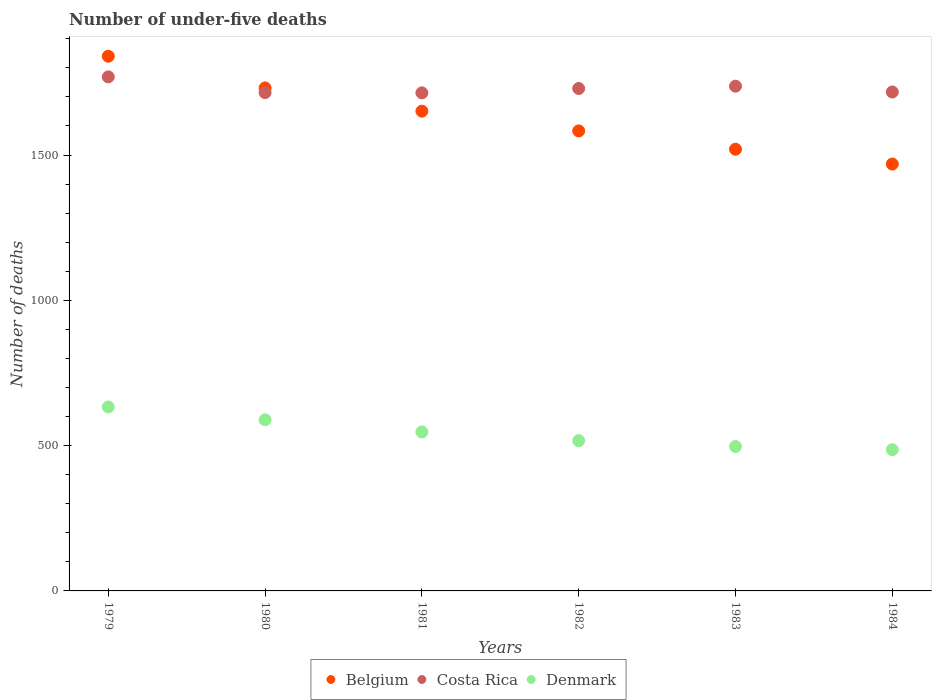How many different coloured dotlines are there?
Your response must be concise. 3. What is the number of under-five deaths in Denmark in 1983?
Give a very brief answer. 497. Across all years, what is the maximum number of under-five deaths in Denmark?
Your answer should be very brief. 633. Across all years, what is the minimum number of under-five deaths in Costa Rica?
Make the answer very short. 1714. In which year was the number of under-five deaths in Belgium maximum?
Give a very brief answer. 1979. What is the total number of under-five deaths in Belgium in the graph?
Provide a short and direct response. 9794. What is the difference between the number of under-five deaths in Costa Rica in 1980 and that in 1984?
Your response must be concise. -2. What is the difference between the number of under-five deaths in Belgium in 1984 and the number of under-five deaths in Costa Rica in 1981?
Keep it short and to the point. -245. What is the average number of under-five deaths in Belgium per year?
Give a very brief answer. 1632.33. In the year 1982, what is the difference between the number of under-five deaths in Denmark and number of under-five deaths in Costa Rica?
Offer a very short reply. -1212. What is the ratio of the number of under-five deaths in Belgium in 1979 to that in 1980?
Your answer should be very brief. 1.06. Is the difference between the number of under-five deaths in Denmark in 1981 and 1983 greater than the difference between the number of under-five deaths in Costa Rica in 1981 and 1983?
Your answer should be compact. Yes. What is the difference between the highest and the lowest number of under-five deaths in Denmark?
Give a very brief answer. 147. In how many years, is the number of under-five deaths in Belgium greater than the average number of under-five deaths in Belgium taken over all years?
Ensure brevity in your answer.  3. Is it the case that in every year, the sum of the number of under-five deaths in Belgium and number of under-five deaths in Denmark  is greater than the number of under-five deaths in Costa Rica?
Offer a very short reply. Yes. Does the number of under-five deaths in Costa Rica monotonically increase over the years?
Ensure brevity in your answer.  No. Is the number of under-five deaths in Belgium strictly greater than the number of under-five deaths in Costa Rica over the years?
Ensure brevity in your answer.  No. How many dotlines are there?
Offer a very short reply. 3. How many years are there in the graph?
Offer a terse response. 6. What is the difference between two consecutive major ticks on the Y-axis?
Your response must be concise. 500. Are the values on the major ticks of Y-axis written in scientific E-notation?
Keep it short and to the point. No. Does the graph contain any zero values?
Offer a terse response. No. Where does the legend appear in the graph?
Keep it short and to the point. Bottom center. How many legend labels are there?
Offer a very short reply. 3. What is the title of the graph?
Provide a short and direct response. Number of under-five deaths. Does "High income" appear as one of the legend labels in the graph?
Offer a terse response. No. What is the label or title of the Y-axis?
Make the answer very short. Number of deaths. What is the Number of deaths of Belgium in 1979?
Keep it short and to the point. 1840. What is the Number of deaths in Costa Rica in 1979?
Provide a succinct answer. 1769. What is the Number of deaths in Denmark in 1979?
Keep it short and to the point. 633. What is the Number of deaths of Belgium in 1980?
Ensure brevity in your answer.  1731. What is the Number of deaths of Costa Rica in 1980?
Provide a short and direct response. 1715. What is the Number of deaths of Denmark in 1980?
Your answer should be compact. 589. What is the Number of deaths in Belgium in 1981?
Your answer should be compact. 1651. What is the Number of deaths in Costa Rica in 1981?
Give a very brief answer. 1714. What is the Number of deaths in Denmark in 1981?
Ensure brevity in your answer.  547. What is the Number of deaths of Belgium in 1982?
Keep it short and to the point. 1583. What is the Number of deaths in Costa Rica in 1982?
Give a very brief answer. 1729. What is the Number of deaths of Denmark in 1982?
Provide a succinct answer. 517. What is the Number of deaths of Belgium in 1983?
Make the answer very short. 1520. What is the Number of deaths in Costa Rica in 1983?
Your response must be concise. 1737. What is the Number of deaths of Denmark in 1983?
Ensure brevity in your answer.  497. What is the Number of deaths of Belgium in 1984?
Provide a succinct answer. 1469. What is the Number of deaths in Costa Rica in 1984?
Make the answer very short. 1717. What is the Number of deaths of Denmark in 1984?
Offer a terse response. 486. Across all years, what is the maximum Number of deaths in Belgium?
Give a very brief answer. 1840. Across all years, what is the maximum Number of deaths in Costa Rica?
Make the answer very short. 1769. Across all years, what is the maximum Number of deaths of Denmark?
Your answer should be compact. 633. Across all years, what is the minimum Number of deaths of Belgium?
Offer a terse response. 1469. Across all years, what is the minimum Number of deaths in Costa Rica?
Ensure brevity in your answer.  1714. Across all years, what is the minimum Number of deaths of Denmark?
Offer a terse response. 486. What is the total Number of deaths in Belgium in the graph?
Your response must be concise. 9794. What is the total Number of deaths of Costa Rica in the graph?
Your answer should be very brief. 1.04e+04. What is the total Number of deaths of Denmark in the graph?
Keep it short and to the point. 3269. What is the difference between the Number of deaths in Belgium in 1979 and that in 1980?
Provide a short and direct response. 109. What is the difference between the Number of deaths in Costa Rica in 1979 and that in 1980?
Your answer should be compact. 54. What is the difference between the Number of deaths of Denmark in 1979 and that in 1980?
Offer a very short reply. 44. What is the difference between the Number of deaths in Belgium in 1979 and that in 1981?
Ensure brevity in your answer.  189. What is the difference between the Number of deaths of Belgium in 1979 and that in 1982?
Ensure brevity in your answer.  257. What is the difference between the Number of deaths in Costa Rica in 1979 and that in 1982?
Your response must be concise. 40. What is the difference between the Number of deaths of Denmark in 1979 and that in 1982?
Make the answer very short. 116. What is the difference between the Number of deaths in Belgium in 1979 and that in 1983?
Your answer should be very brief. 320. What is the difference between the Number of deaths in Denmark in 1979 and that in 1983?
Keep it short and to the point. 136. What is the difference between the Number of deaths of Belgium in 1979 and that in 1984?
Ensure brevity in your answer.  371. What is the difference between the Number of deaths of Costa Rica in 1979 and that in 1984?
Your answer should be compact. 52. What is the difference between the Number of deaths of Denmark in 1979 and that in 1984?
Give a very brief answer. 147. What is the difference between the Number of deaths of Costa Rica in 1980 and that in 1981?
Give a very brief answer. 1. What is the difference between the Number of deaths of Denmark in 1980 and that in 1981?
Your answer should be very brief. 42. What is the difference between the Number of deaths in Belgium in 1980 and that in 1982?
Offer a terse response. 148. What is the difference between the Number of deaths in Costa Rica in 1980 and that in 1982?
Your answer should be very brief. -14. What is the difference between the Number of deaths in Denmark in 1980 and that in 1982?
Give a very brief answer. 72. What is the difference between the Number of deaths of Belgium in 1980 and that in 1983?
Your answer should be very brief. 211. What is the difference between the Number of deaths of Costa Rica in 1980 and that in 1983?
Provide a short and direct response. -22. What is the difference between the Number of deaths of Denmark in 1980 and that in 1983?
Keep it short and to the point. 92. What is the difference between the Number of deaths in Belgium in 1980 and that in 1984?
Your answer should be compact. 262. What is the difference between the Number of deaths of Denmark in 1980 and that in 1984?
Your answer should be compact. 103. What is the difference between the Number of deaths in Denmark in 1981 and that in 1982?
Ensure brevity in your answer.  30. What is the difference between the Number of deaths of Belgium in 1981 and that in 1983?
Provide a succinct answer. 131. What is the difference between the Number of deaths in Denmark in 1981 and that in 1983?
Offer a terse response. 50. What is the difference between the Number of deaths of Belgium in 1981 and that in 1984?
Offer a terse response. 182. What is the difference between the Number of deaths of Belgium in 1982 and that in 1983?
Your response must be concise. 63. What is the difference between the Number of deaths of Belgium in 1982 and that in 1984?
Provide a short and direct response. 114. What is the difference between the Number of deaths of Costa Rica in 1982 and that in 1984?
Your answer should be compact. 12. What is the difference between the Number of deaths of Costa Rica in 1983 and that in 1984?
Provide a succinct answer. 20. What is the difference between the Number of deaths in Denmark in 1983 and that in 1984?
Provide a short and direct response. 11. What is the difference between the Number of deaths in Belgium in 1979 and the Number of deaths in Costa Rica in 1980?
Your answer should be compact. 125. What is the difference between the Number of deaths of Belgium in 1979 and the Number of deaths of Denmark in 1980?
Offer a terse response. 1251. What is the difference between the Number of deaths in Costa Rica in 1979 and the Number of deaths in Denmark in 1980?
Your answer should be very brief. 1180. What is the difference between the Number of deaths of Belgium in 1979 and the Number of deaths of Costa Rica in 1981?
Provide a succinct answer. 126. What is the difference between the Number of deaths in Belgium in 1979 and the Number of deaths in Denmark in 1981?
Your answer should be very brief. 1293. What is the difference between the Number of deaths of Costa Rica in 1979 and the Number of deaths of Denmark in 1981?
Your response must be concise. 1222. What is the difference between the Number of deaths of Belgium in 1979 and the Number of deaths of Costa Rica in 1982?
Provide a succinct answer. 111. What is the difference between the Number of deaths of Belgium in 1979 and the Number of deaths of Denmark in 1982?
Provide a short and direct response. 1323. What is the difference between the Number of deaths of Costa Rica in 1979 and the Number of deaths of Denmark in 1982?
Your response must be concise. 1252. What is the difference between the Number of deaths in Belgium in 1979 and the Number of deaths in Costa Rica in 1983?
Ensure brevity in your answer.  103. What is the difference between the Number of deaths in Belgium in 1979 and the Number of deaths in Denmark in 1983?
Ensure brevity in your answer.  1343. What is the difference between the Number of deaths of Costa Rica in 1979 and the Number of deaths of Denmark in 1983?
Your answer should be compact. 1272. What is the difference between the Number of deaths of Belgium in 1979 and the Number of deaths of Costa Rica in 1984?
Your answer should be very brief. 123. What is the difference between the Number of deaths of Belgium in 1979 and the Number of deaths of Denmark in 1984?
Ensure brevity in your answer.  1354. What is the difference between the Number of deaths in Costa Rica in 1979 and the Number of deaths in Denmark in 1984?
Provide a short and direct response. 1283. What is the difference between the Number of deaths in Belgium in 1980 and the Number of deaths in Denmark in 1981?
Keep it short and to the point. 1184. What is the difference between the Number of deaths in Costa Rica in 1980 and the Number of deaths in Denmark in 1981?
Keep it short and to the point. 1168. What is the difference between the Number of deaths of Belgium in 1980 and the Number of deaths of Denmark in 1982?
Provide a succinct answer. 1214. What is the difference between the Number of deaths in Costa Rica in 1980 and the Number of deaths in Denmark in 1982?
Keep it short and to the point. 1198. What is the difference between the Number of deaths in Belgium in 1980 and the Number of deaths in Denmark in 1983?
Your response must be concise. 1234. What is the difference between the Number of deaths of Costa Rica in 1980 and the Number of deaths of Denmark in 1983?
Your answer should be compact. 1218. What is the difference between the Number of deaths in Belgium in 1980 and the Number of deaths in Denmark in 1984?
Provide a succinct answer. 1245. What is the difference between the Number of deaths of Costa Rica in 1980 and the Number of deaths of Denmark in 1984?
Offer a terse response. 1229. What is the difference between the Number of deaths in Belgium in 1981 and the Number of deaths in Costa Rica in 1982?
Give a very brief answer. -78. What is the difference between the Number of deaths of Belgium in 1981 and the Number of deaths of Denmark in 1982?
Keep it short and to the point. 1134. What is the difference between the Number of deaths in Costa Rica in 1981 and the Number of deaths in Denmark in 1982?
Provide a short and direct response. 1197. What is the difference between the Number of deaths in Belgium in 1981 and the Number of deaths in Costa Rica in 1983?
Ensure brevity in your answer.  -86. What is the difference between the Number of deaths of Belgium in 1981 and the Number of deaths of Denmark in 1983?
Give a very brief answer. 1154. What is the difference between the Number of deaths in Costa Rica in 1981 and the Number of deaths in Denmark in 1983?
Your answer should be very brief. 1217. What is the difference between the Number of deaths in Belgium in 1981 and the Number of deaths in Costa Rica in 1984?
Make the answer very short. -66. What is the difference between the Number of deaths in Belgium in 1981 and the Number of deaths in Denmark in 1984?
Provide a succinct answer. 1165. What is the difference between the Number of deaths in Costa Rica in 1981 and the Number of deaths in Denmark in 1984?
Offer a terse response. 1228. What is the difference between the Number of deaths in Belgium in 1982 and the Number of deaths in Costa Rica in 1983?
Provide a short and direct response. -154. What is the difference between the Number of deaths in Belgium in 1982 and the Number of deaths in Denmark in 1983?
Give a very brief answer. 1086. What is the difference between the Number of deaths in Costa Rica in 1982 and the Number of deaths in Denmark in 1983?
Your response must be concise. 1232. What is the difference between the Number of deaths in Belgium in 1982 and the Number of deaths in Costa Rica in 1984?
Ensure brevity in your answer.  -134. What is the difference between the Number of deaths of Belgium in 1982 and the Number of deaths of Denmark in 1984?
Keep it short and to the point. 1097. What is the difference between the Number of deaths in Costa Rica in 1982 and the Number of deaths in Denmark in 1984?
Provide a succinct answer. 1243. What is the difference between the Number of deaths of Belgium in 1983 and the Number of deaths of Costa Rica in 1984?
Provide a short and direct response. -197. What is the difference between the Number of deaths of Belgium in 1983 and the Number of deaths of Denmark in 1984?
Keep it short and to the point. 1034. What is the difference between the Number of deaths in Costa Rica in 1983 and the Number of deaths in Denmark in 1984?
Your answer should be compact. 1251. What is the average Number of deaths of Belgium per year?
Your answer should be compact. 1632.33. What is the average Number of deaths of Costa Rica per year?
Your answer should be very brief. 1730.17. What is the average Number of deaths in Denmark per year?
Keep it short and to the point. 544.83. In the year 1979, what is the difference between the Number of deaths of Belgium and Number of deaths of Denmark?
Ensure brevity in your answer.  1207. In the year 1979, what is the difference between the Number of deaths in Costa Rica and Number of deaths in Denmark?
Provide a succinct answer. 1136. In the year 1980, what is the difference between the Number of deaths in Belgium and Number of deaths in Costa Rica?
Offer a terse response. 16. In the year 1980, what is the difference between the Number of deaths of Belgium and Number of deaths of Denmark?
Make the answer very short. 1142. In the year 1980, what is the difference between the Number of deaths of Costa Rica and Number of deaths of Denmark?
Provide a succinct answer. 1126. In the year 1981, what is the difference between the Number of deaths of Belgium and Number of deaths of Costa Rica?
Offer a very short reply. -63. In the year 1981, what is the difference between the Number of deaths in Belgium and Number of deaths in Denmark?
Provide a short and direct response. 1104. In the year 1981, what is the difference between the Number of deaths of Costa Rica and Number of deaths of Denmark?
Give a very brief answer. 1167. In the year 1982, what is the difference between the Number of deaths of Belgium and Number of deaths of Costa Rica?
Offer a very short reply. -146. In the year 1982, what is the difference between the Number of deaths in Belgium and Number of deaths in Denmark?
Provide a succinct answer. 1066. In the year 1982, what is the difference between the Number of deaths in Costa Rica and Number of deaths in Denmark?
Provide a short and direct response. 1212. In the year 1983, what is the difference between the Number of deaths of Belgium and Number of deaths of Costa Rica?
Give a very brief answer. -217. In the year 1983, what is the difference between the Number of deaths of Belgium and Number of deaths of Denmark?
Provide a short and direct response. 1023. In the year 1983, what is the difference between the Number of deaths in Costa Rica and Number of deaths in Denmark?
Your answer should be very brief. 1240. In the year 1984, what is the difference between the Number of deaths in Belgium and Number of deaths in Costa Rica?
Provide a succinct answer. -248. In the year 1984, what is the difference between the Number of deaths in Belgium and Number of deaths in Denmark?
Your response must be concise. 983. In the year 1984, what is the difference between the Number of deaths in Costa Rica and Number of deaths in Denmark?
Ensure brevity in your answer.  1231. What is the ratio of the Number of deaths in Belgium in 1979 to that in 1980?
Your answer should be very brief. 1.06. What is the ratio of the Number of deaths of Costa Rica in 1979 to that in 1980?
Ensure brevity in your answer.  1.03. What is the ratio of the Number of deaths of Denmark in 1979 to that in 1980?
Make the answer very short. 1.07. What is the ratio of the Number of deaths of Belgium in 1979 to that in 1981?
Give a very brief answer. 1.11. What is the ratio of the Number of deaths of Costa Rica in 1979 to that in 1981?
Offer a terse response. 1.03. What is the ratio of the Number of deaths in Denmark in 1979 to that in 1981?
Keep it short and to the point. 1.16. What is the ratio of the Number of deaths in Belgium in 1979 to that in 1982?
Keep it short and to the point. 1.16. What is the ratio of the Number of deaths of Costa Rica in 1979 to that in 1982?
Your answer should be very brief. 1.02. What is the ratio of the Number of deaths in Denmark in 1979 to that in 1982?
Ensure brevity in your answer.  1.22. What is the ratio of the Number of deaths of Belgium in 1979 to that in 1983?
Ensure brevity in your answer.  1.21. What is the ratio of the Number of deaths of Costa Rica in 1979 to that in 1983?
Your response must be concise. 1.02. What is the ratio of the Number of deaths in Denmark in 1979 to that in 1983?
Your answer should be very brief. 1.27. What is the ratio of the Number of deaths of Belgium in 1979 to that in 1984?
Ensure brevity in your answer.  1.25. What is the ratio of the Number of deaths of Costa Rica in 1979 to that in 1984?
Offer a terse response. 1.03. What is the ratio of the Number of deaths in Denmark in 1979 to that in 1984?
Your answer should be very brief. 1.3. What is the ratio of the Number of deaths in Belgium in 1980 to that in 1981?
Provide a succinct answer. 1.05. What is the ratio of the Number of deaths of Denmark in 1980 to that in 1981?
Your response must be concise. 1.08. What is the ratio of the Number of deaths in Belgium in 1980 to that in 1982?
Offer a very short reply. 1.09. What is the ratio of the Number of deaths in Denmark in 1980 to that in 1982?
Ensure brevity in your answer.  1.14. What is the ratio of the Number of deaths of Belgium in 1980 to that in 1983?
Ensure brevity in your answer.  1.14. What is the ratio of the Number of deaths in Costa Rica in 1980 to that in 1983?
Your answer should be compact. 0.99. What is the ratio of the Number of deaths in Denmark in 1980 to that in 1983?
Your answer should be very brief. 1.19. What is the ratio of the Number of deaths of Belgium in 1980 to that in 1984?
Ensure brevity in your answer.  1.18. What is the ratio of the Number of deaths of Costa Rica in 1980 to that in 1984?
Provide a succinct answer. 1. What is the ratio of the Number of deaths of Denmark in 1980 to that in 1984?
Provide a succinct answer. 1.21. What is the ratio of the Number of deaths of Belgium in 1981 to that in 1982?
Offer a very short reply. 1.04. What is the ratio of the Number of deaths in Denmark in 1981 to that in 1982?
Offer a very short reply. 1.06. What is the ratio of the Number of deaths of Belgium in 1981 to that in 1983?
Your response must be concise. 1.09. What is the ratio of the Number of deaths in Denmark in 1981 to that in 1983?
Keep it short and to the point. 1.1. What is the ratio of the Number of deaths in Belgium in 1981 to that in 1984?
Offer a terse response. 1.12. What is the ratio of the Number of deaths of Denmark in 1981 to that in 1984?
Keep it short and to the point. 1.13. What is the ratio of the Number of deaths of Belgium in 1982 to that in 1983?
Offer a terse response. 1.04. What is the ratio of the Number of deaths of Costa Rica in 1982 to that in 1983?
Provide a succinct answer. 1. What is the ratio of the Number of deaths of Denmark in 1982 to that in 1983?
Give a very brief answer. 1.04. What is the ratio of the Number of deaths in Belgium in 1982 to that in 1984?
Keep it short and to the point. 1.08. What is the ratio of the Number of deaths of Denmark in 1982 to that in 1984?
Ensure brevity in your answer.  1.06. What is the ratio of the Number of deaths in Belgium in 1983 to that in 1984?
Your response must be concise. 1.03. What is the ratio of the Number of deaths of Costa Rica in 1983 to that in 1984?
Keep it short and to the point. 1.01. What is the ratio of the Number of deaths in Denmark in 1983 to that in 1984?
Make the answer very short. 1.02. What is the difference between the highest and the second highest Number of deaths of Belgium?
Offer a terse response. 109. What is the difference between the highest and the second highest Number of deaths in Costa Rica?
Provide a short and direct response. 32. What is the difference between the highest and the second highest Number of deaths of Denmark?
Ensure brevity in your answer.  44. What is the difference between the highest and the lowest Number of deaths in Belgium?
Your answer should be very brief. 371. What is the difference between the highest and the lowest Number of deaths in Denmark?
Make the answer very short. 147. 